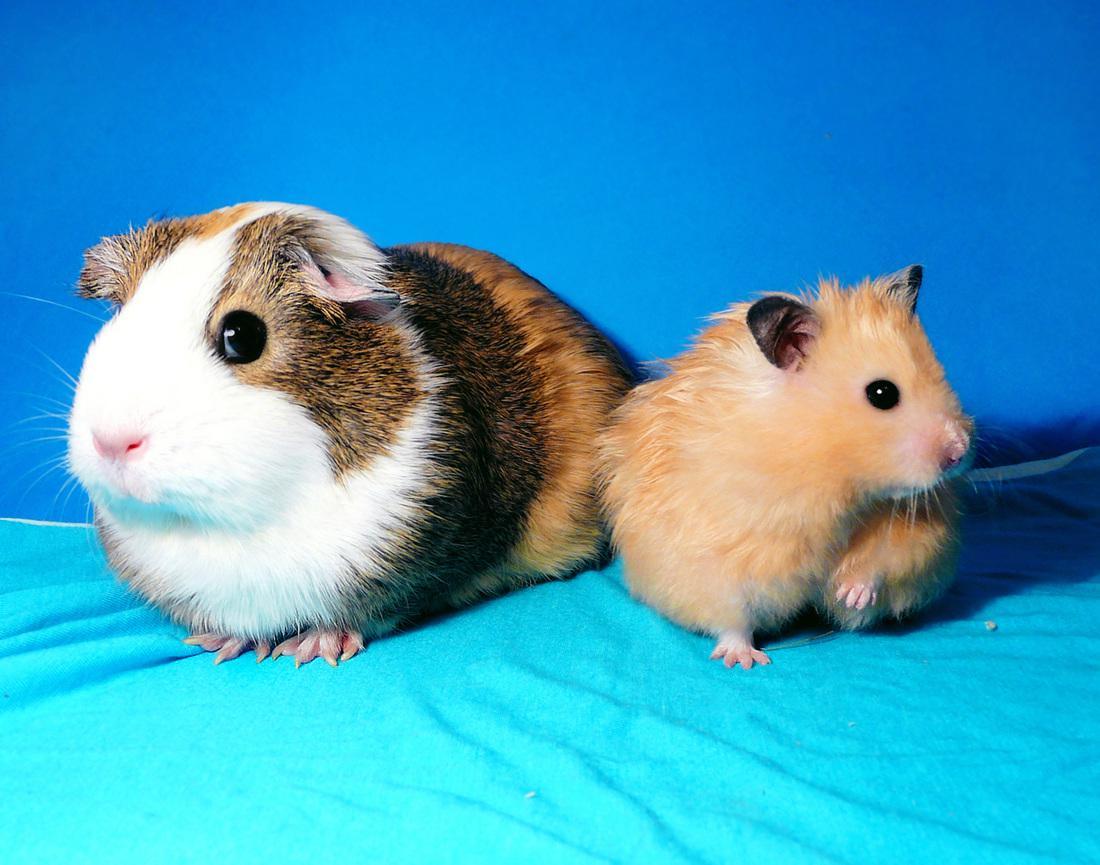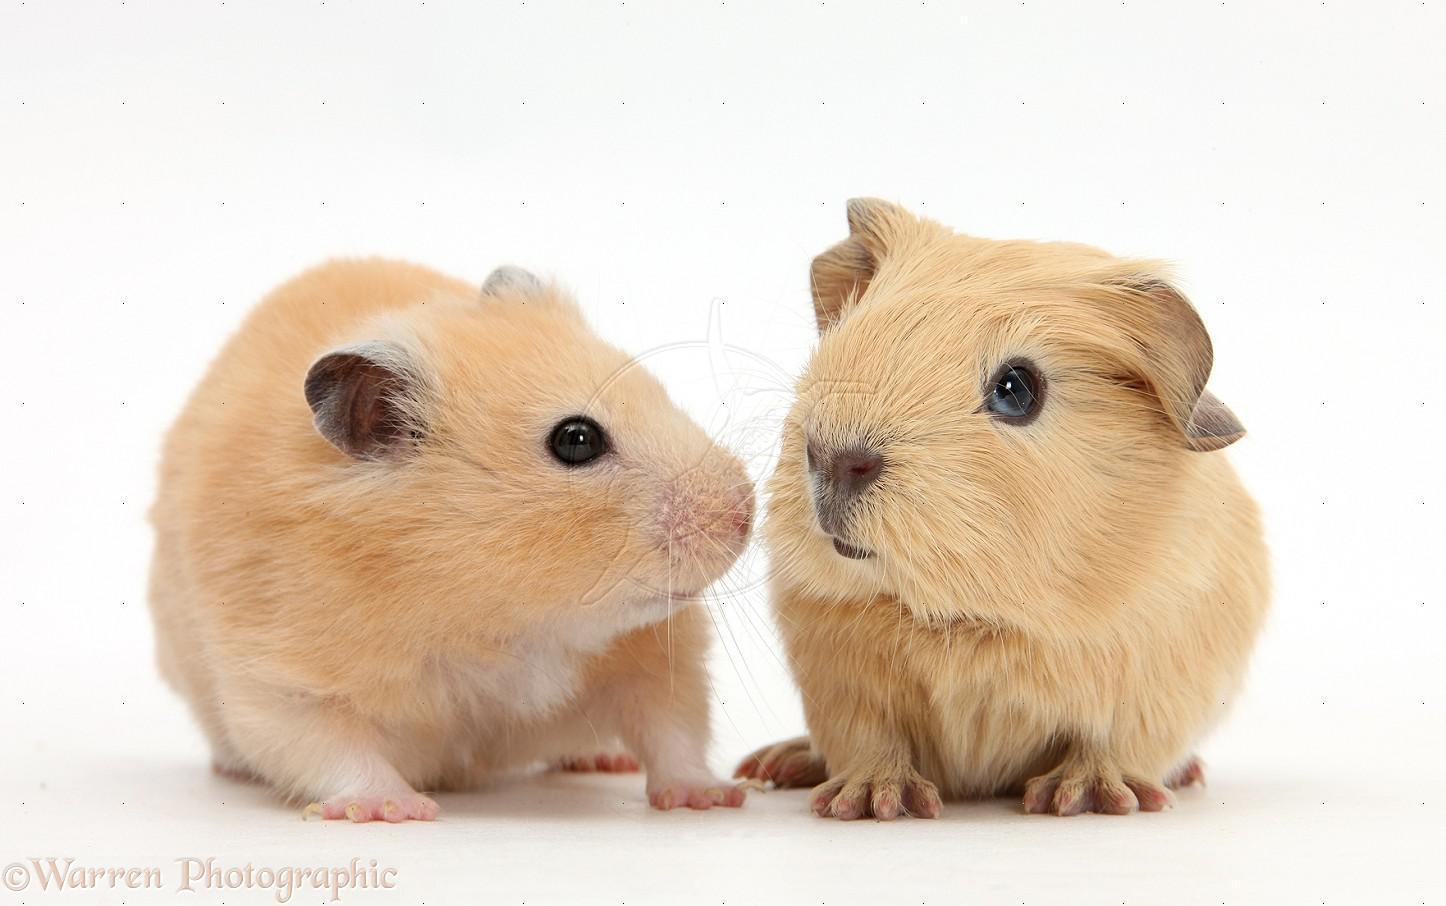The first image is the image on the left, the second image is the image on the right. For the images shown, is this caption "A total of three rodent-type pets are shown." true? Answer yes or no. No. 